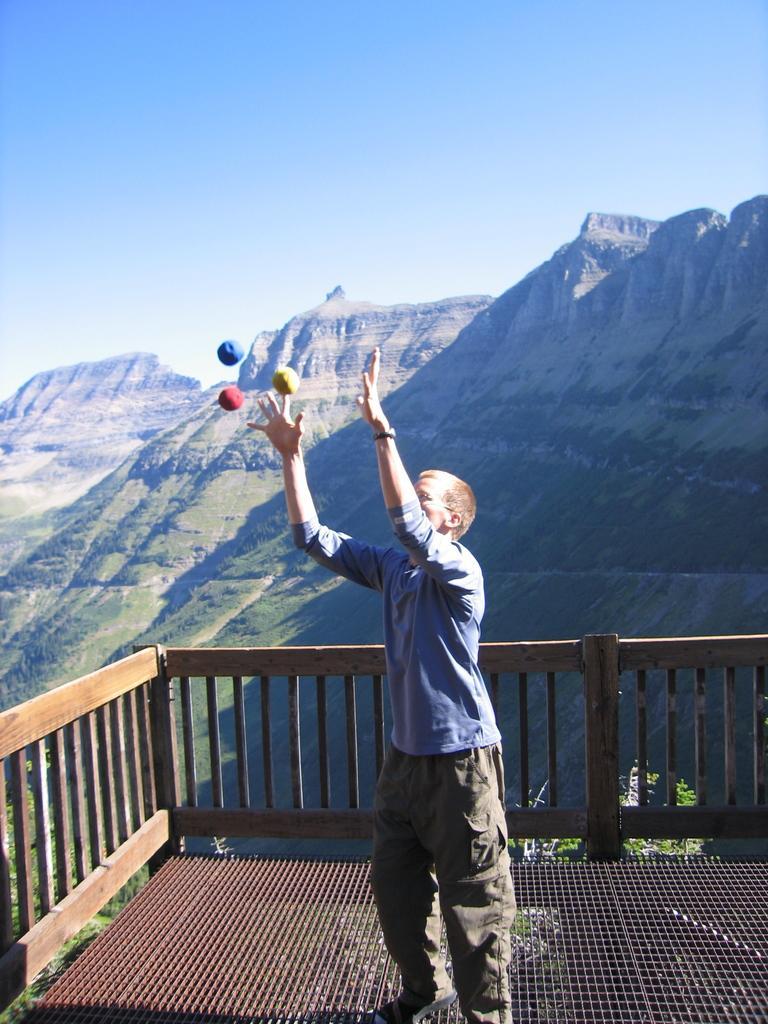How would you summarize this image in a sentence or two? In this image, we can see a person standing on the floor. We can see some colored balls. We can see the fence. There is a plant behind the fence. There are some hills. We can see some grass. We can also see the sky. 